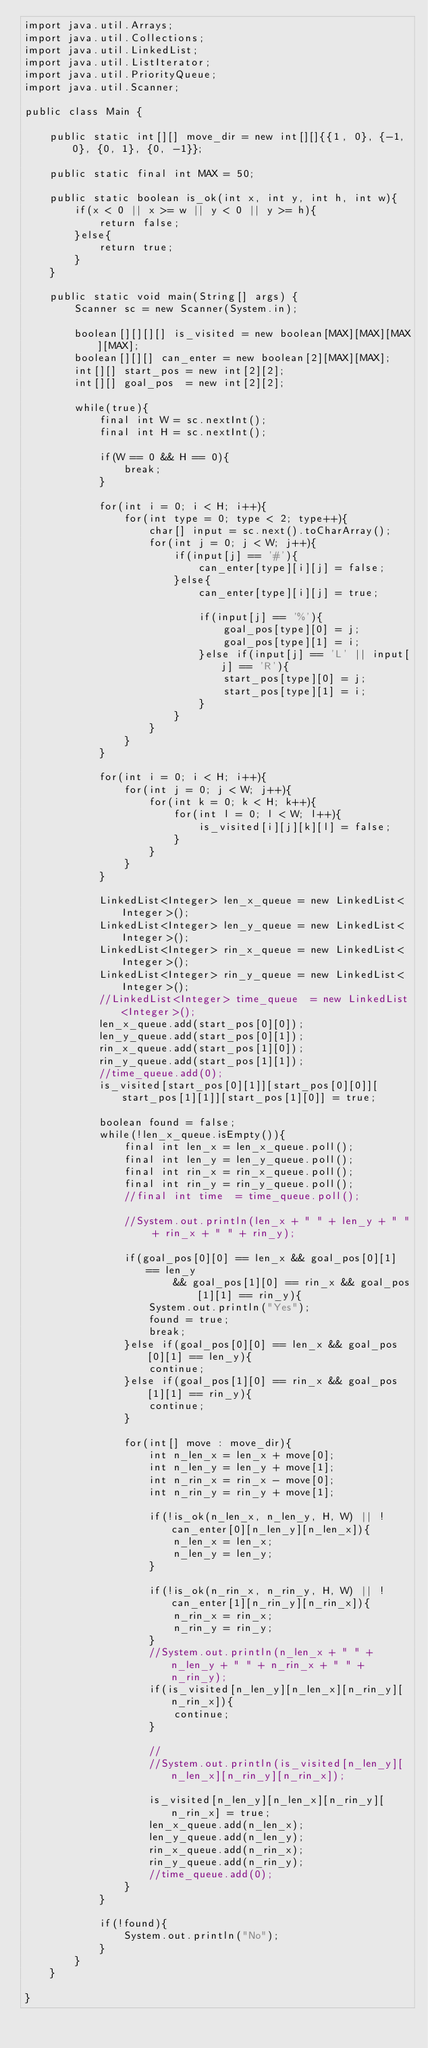<code> <loc_0><loc_0><loc_500><loc_500><_Java_>import java.util.Arrays;
import java.util.Collections;
import java.util.LinkedList;
import java.util.ListIterator;
import java.util.PriorityQueue;
import java.util.Scanner;

public class Main {
	
	public static int[][] move_dir = new int[][]{{1, 0}, {-1, 0}, {0, 1}, {0, -1}};
	
	public static final int MAX = 50;
	
	public static boolean is_ok(int x, int y, int h, int w){
		if(x < 0 || x >= w || y < 0 || y >= h){
			return false;
		}else{
			return true;
		}
	}
	
	public static void main(String[] args) {
		Scanner sc = new Scanner(System.in);
		
		boolean[][][][] is_visited = new boolean[MAX][MAX][MAX][MAX];
		boolean[][][] can_enter = new boolean[2][MAX][MAX];
		int[][] start_pos = new int[2][2];
		int[][] goal_pos  = new int[2][2];
		
		while(true){
			final int W = sc.nextInt();
			final int H = sc.nextInt();
			
			if(W == 0 && H == 0){
				break;
			}
			
			for(int i = 0; i < H; i++){
				for(int type = 0; type < 2; type++){
					char[] input = sc.next().toCharArray();
					for(int j = 0; j < W; j++){
						if(input[j] == '#'){
							can_enter[type][i][j] = false;
						}else{
							can_enter[type][i][j] = true;
							
							if(input[j] == '%'){
								goal_pos[type][0] = j;
								goal_pos[type][1] = i;
							}else if(input[j] == 'L' || input[j] == 'R'){
								start_pos[type][0] = j;
								start_pos[type][1] = i;
							}
						}
					}
				}
			}
			
			for(int i = 0; i < H; i++){
				for(int j = 0; j < W; j++){
					for(int k = 0; k < H; k++){
						for(int l = 0; l < W; l++){
							is_visited[i][j][k][l] = false;
						}
					}
				}
			}
			
			LinkedList<Integer> len_x_queue = new LinkedList<Integer>();
			LinkedList<Integer> len_y_queue = new LinkedList<Integer>();
			LinkedList<Integer> rin_x_queue = new LinkedList<Integer>();
			LinkedList<Integer> rin_y_queue = new LinkedList<Integer>();
			//LinkedList<Integer> time_queue  = new LinkedList<Integer>();
			len_x_queue.add(start_pos[0][0]);
			len_y_queue.add(start_pos[0][1]);
			rin_x_queue.add(start_pos[1][0]);
			rin_y_queue.add(start_pos[1][1]);
			//time_queue.add(0);
			is_visited[start_pos[0][1]][start_pos[0][0]][start_pos[1][1]][start_pos[1][0]] = true;
			
			boolean found = false;
			while(!len_x_queue.isEmpty()){
				final int len_x = len_x_queue.poll();
				final int len_y = len_y_queue.poll();
				final int rin_x = rin_x_queue.poll();
				final int rin_y = rin_y_queue.poll();
				//final int time  = time_queue.poll();
				
				//System.out.println(len_x + " " + len_y + " " + rin_x + " " + rin_y);
				
				if(goal_pos[0][0] == len_x && goal_pos[0][1] == len_y
						&& goal_pos[1][0] == rin_x && goal_pos[1][1] == rin_y){
					System.out.println("Yes");
					found = true;
					break;
				}else if(goal_pos[0][0] == len_x && goal_pos[0][1] == len_y){
					continue;
				}else if(goal_pos[1][0] == rin_x && goal_pos[1][1] == rin_y){
					continue;
				}
				
				for(int[] move : move_dir){
					int n_len_x = len_x + move[0];
					int n_len_y = len_y + move[1];
					int n_rin_x = rin_x - move[0];
					int n_rin_y = rin_y + move[1];
					
					if(!is_ok(n_len_x, n_len_y, H, W) || !can_enter[0][n_len_y][n_len_x]){
						n_len_x = len_x;
						n_len_y = len_y;
					}
					
					if(!is_ok(n_rin_x, n_rin_y, H, W) || !can_enter[1][n_rin_y][n_rin_x]){
						n_rin_x = rin_x;
						n_rin_y = rin_y;
					}
					//System.out.println(n_len_x + " " + n_len_y + " " + n_rin_x + " " + n_rin_y);
					if(is_visited[n_len_y][n_len_x][n_rin_y][n_rin_x]){
						continue;
					}
					
					//
					//System.out.println(is_visited[n_len_y][n_len_x][n_rin_y][n_rin_x]);
					
					is_visited[n_len_y][n_len_x][n_rin_y][n_rin_x] = true;
					len_x_queue.add(n_len_x);
					len_y_queue.add(n_len_y);
					rin_x_queue.add(n_rin_x);
					rin_y_queue.add(n_rin_y);
					//time_queue.add(0);
				}
			}
			
			if(!found){
				System.out.println("No");
			}
		}
	}

}</code> 